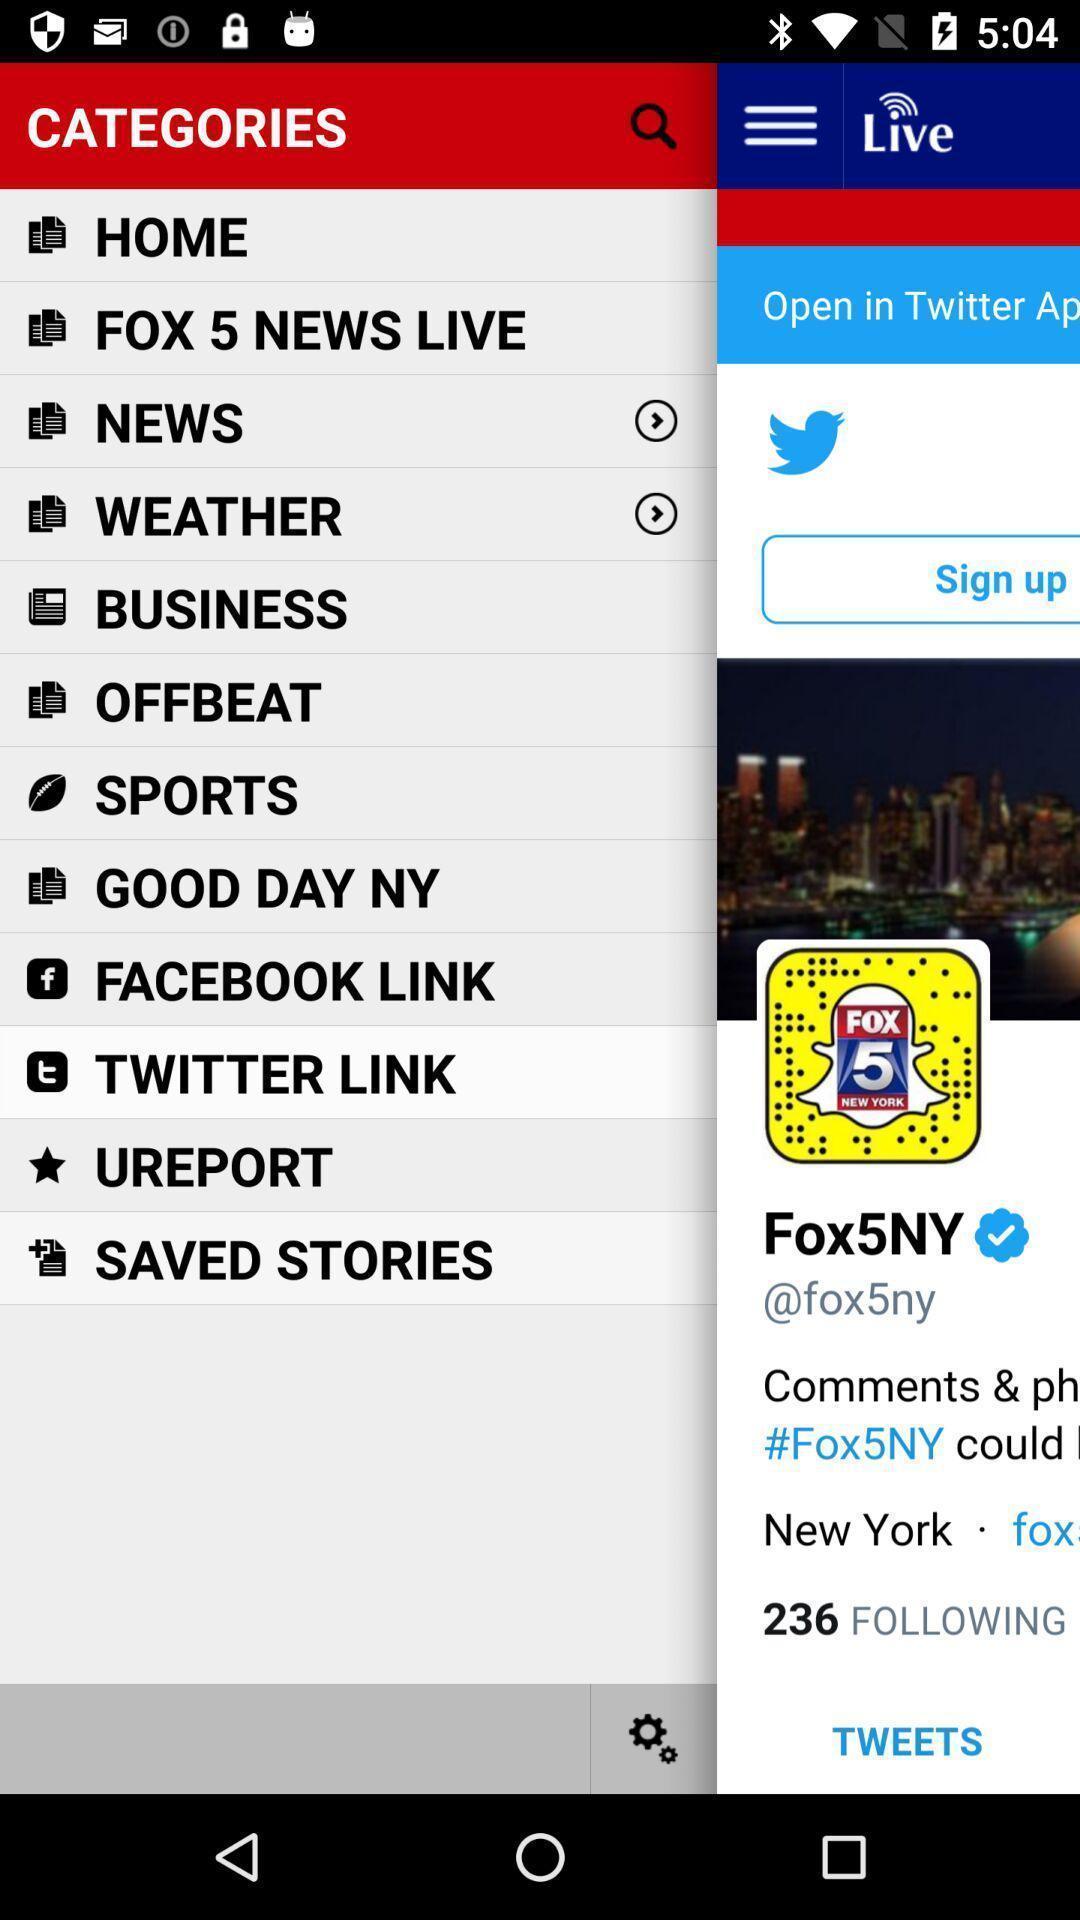What is the overall content of this screenshot? Page showing different options like home. 